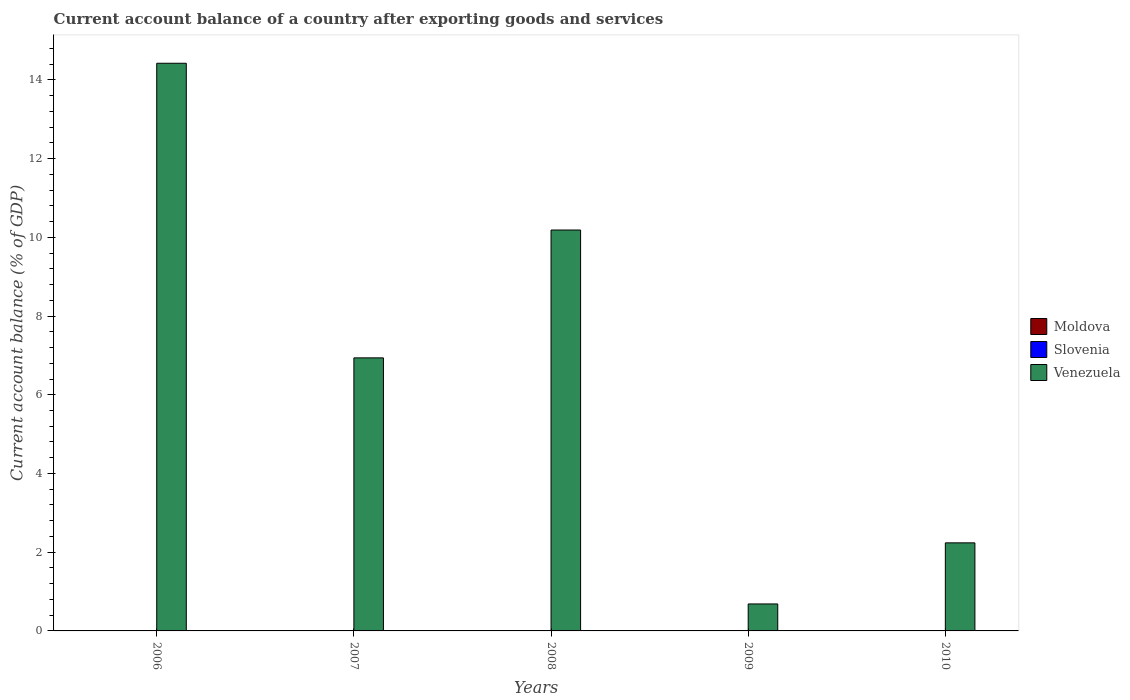Are the number of bars per tick equal to the number of legend labels?
Your answer should be compact. No. Are the number of bars on each tick of the X-axis equal?
Your answer should be compact. Yes. How many bars are there on the 1st tick from the left?
Your answer should be very brief. 1. Across all years, what is the maximum account balance in Venezuela?
Your answer should be very brief. 14.42. What is the total account balance in Moldova in the graph?
Make the answer very short. 0. What is the difference between the account balance in Venezuela in 2006 and that in 2009?
Your response must be concise. 13.74. What is the difference between the account balance in Venezuela in 2007 and the account balance in Moldova in 2006?
Your answer should be compact. 6.94. What is the ratio of the account balance in Venezuela in 2007 to that in 2009?
Make the answer very short. 10.12. What is the difference between the highest and the second highest account balance in Venezuela?
Make the answer very short. 4.24. What is the difference between the highest and the lowest account balance in Venezuela?
Offer a very short reply. 13.74. Is the sum of the account balance in Venezuela in 2007 and 2010 greater than the maximum account balance in Moldova across all years?
Provide a succinct answer. Yes. Is it the case that in every year, the sum of the account balance in Venezuela and account balance in Slovenia is greater than the account balance in Moldova?
Offer a very short reply. Yes. How many bars are there?
Keep it short and to the point. 5. How many years are there in the graph?
Give a very brief answer. 5. What is the difference between two consecutive major ticks on the Y-axis?
Provide a succinct answer. 2. Are the values on the major ticks of Y-axis written in scientific E-notation?
Make the answer very short. No. Where does the legend appear in the graph?
Your answer should be compact. Center right. How many legend labels are there?
Your response must be concise. 3. How are the legend labels stacked?
Your response must be concise. Vertical. What is the title of the graph?
Your answer should be very brief. Current account balance of a country after exporting goods and services. Does "Montenegro" appear as one of the legend labels in the graph?
Give a very brief answer. No. What is the label or title of the X-axis?
Make the answer very short. Years. What is the label or title of the Y-axis?
Ensure brevity in your answer.  Current account balance (% of GDP). What is the Current account balance (% of GDP) in Slovenia in 2006?
Offer a terse response. 0. What is the Current account balance (% of GDP) in Venezuela in 2006?
Your response must be concise. 14.42. What is the Current account balance (% of GDP) of Venezuela in 2007?
Offer a terse response. 6.94. What is the Current account balance (% of GDP) in Slovenia in 2008?
Give a very brief answer. 0. What is the Current account balance (% of GDP) in Venezuela in 2008?
Give a very brief answer. 10.19. What is the Current account balance (% of GDP) in Moldova in 2009?
Ensure brevity in your answer.  0. What is the Current account balance (% of GDP) in Venezuela in 2009?
Provide a succinct answer. 0.69. What is the Current account balance (% of GDP) of Moldova in 2010?
Make the answer very short. 0. What is the Current account balance (% of GDP) of Venezuela in 2010?
Make the answer very short. 2.24. Across all years, what is the maximum Current account balance (% of GDP) in Venezuela?
Your answer should be very brief. 14.42. Across all years, what is the minimum Current account balance (% of GDP) in Venezuela?
Give a very brief answer. 0.69. What is the total Current account balance (% of GDP) in Moldova in the graph?
Ensure brevity in your answer.  0. What is the total Current account balance (% of GDP) of Venezuela in the graph?
Provide a succinct answer. 34.47. What is the difference between the Current account balance (% of GDP) of Venezuela in 2006 and that in 2007?
Ensure brevity in your answer.  7.49. What is the difference between the Current account balance (% of GDP) in Venezuela in 2006 and that in 2008?
Keep it short and to the point. 4.24. What is the difference between the Current account balance (% of GDP) in Venezuela in 2006 and that in 2009?
Make the answer very short. 13.74. What is the difference between the Current account balance (% of GDP) of Venezuela in 2006 and that in 2010?
Your answer should be compact. 12.18. What is the difference between the Current account balance (% of GDP) of Venezuela in 2007 and that in 2008?
Your response must be concise. -3.25. What is the difference between the Current account balance (% of GDP) of Venezuela in 2007 and that in 2009?
Ensure brevity in your answer.  6.25. What is the difference between the Current account balance (% of GDP) of Venezuela in 2007 and that in 2010?
Offer a very short reply. 4.7. What is the difference between the Current account balance (% of GDP) in Venezuela in 2008 and that in 2009?
Your answer should be very brief. 9.5. What is the difference between the Current account balance (% of GDP) of Venezuela in 2008 and that in 2010?
Your response must be concise. 7.95. What is the difference between the Current account balance (% of GDP) of Venezuela in 2009 and that in 2010?
Offer a terse response. -1.55. What is the average Current account balance (% of GDP) in Moldova per year?
Offer a very short reply. 0. What is the average Current account balance (% of GDP) in Venezuela per year?
Your answer should be compact. 6.89. What is the ratio of the Current account balance (% of GDP) of Venezuela in 2006 to that in 2007?
Provide a short and direct response. 2.08. What is the ratio of the Current account balance (% of GDP) of Venezuela in 2006 to that in 2008?
Your answer should be compact. 1.42. What is the ratio of the Current account balance (% of GDP) in Venezuela in 2006 to that in 2009?
Your answer should be very brief. 21.04. What is the ratio of the Current account balance (% of GDP) of Venezuela in 2006 to that in 2010?
Your response must be concise. 6.45. What is the ratio of the Current account balance (% of GDP) of Venezuela in 2007 to that in 2008?
Offer a very short reply. 0.68. What is the ratio of the Current account balance (% of GDP) of Venezuela in 2007 to that in 2009?
Ensure brevity in your answer.  10.12. What is the ratio of the Current account balance (% of GDP) in Venezuela in 2007 to that in 2010?
Keep it short and to the point. 3.1. What is the ratio of the Current account balance (% of GDP) of Venezuela in 2008 to that in 2009?
Offer a very short reply. 14.86. What is the ratio of the Current account balance (% of GDP) in Venezuela in 2008 to that in 2010?
Offer a very short reply. 4.55. What is the ratio of the Current account balance (% of GDP) of Venezuela in 2009 to that in 2010?
Your answer should be very brief. 0.31. What is the difference between the highest and the second highest Current account balance (% of GDP) in Venezuela?
Give a very brief answer. 4.24. What is the difference between the highest and the lowest Current account balance (% of GDP) in Venezuela?
Your answer should be compact. 13.74. 